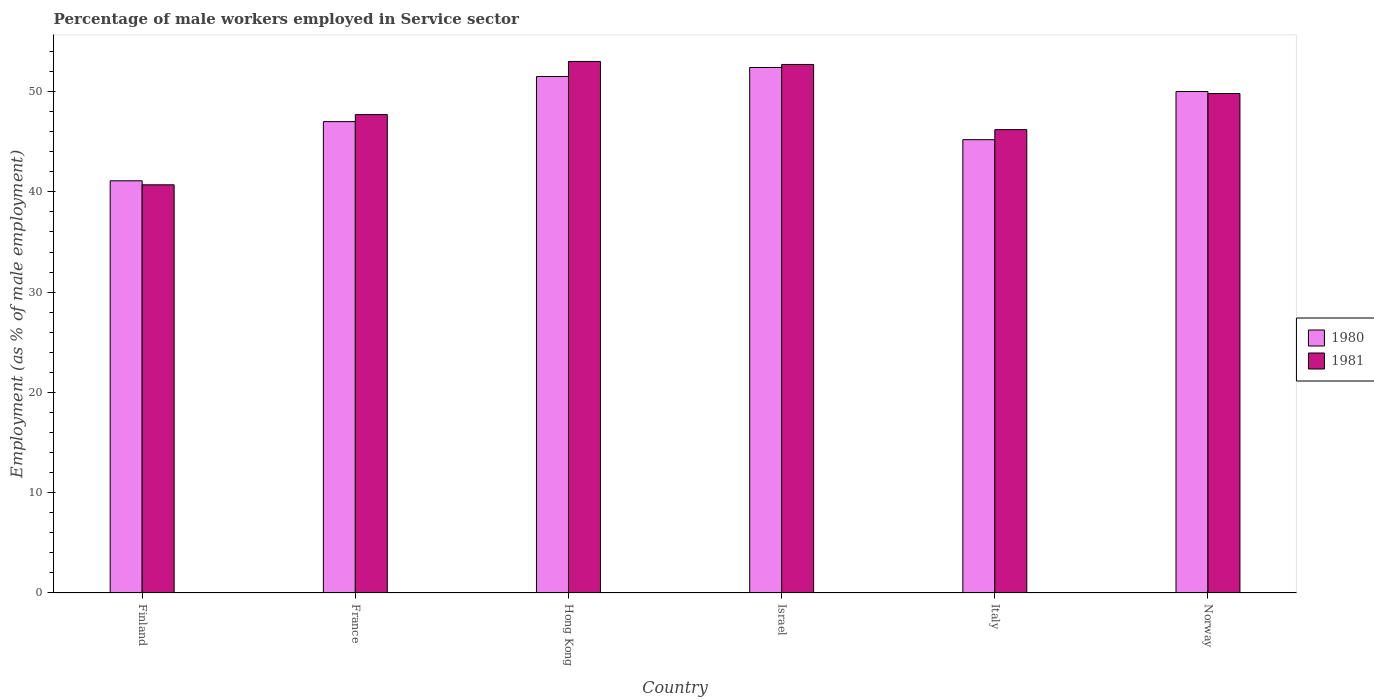How many groups of bars are there?
Ensure brevity in your answer.  6. How many bars are there on the 5th tick from the left?
Your answer should be compact. 2. What is the label of the 2nd group of bars from the left?
Offer a terse response. France. Across all countries, what is the maximum percentage of male workers employed in Service sector in 1981?
Offer a very short reply. 53. Across all countries, what is the minimum percentage of male workers employed in Service sector in 1980?
Your response must be concise. 41.1. What is the total percentage of male workers employed in Service sector in 1981 in the graph?
Your response must be concise. 290.1. What is the difference between the percentage of male workers employed in Service sector in 1981 in Finland and that in Hong Kong?
Your answer should be very brief. -12.3. What is the difference between the percentage of male workers employed in Service sector in 1980 in Finland and the percentage of male workers employed in Service sector in 1981 in Israel?
Provide a short and direct response. -11.6. What is the average percentage of male workers employed in Service sector in 1981 per country?
Ensure brevity in your answer.  48.35. What is the difference between the percentage of male workers employed in Service sector of/in 1980 and percentage of male workers employed in Service sector of/in 1981 in Israel?
Your answer should be compact. -0.3. What is the ratio of the percentage of male workers employed in Service sector in 1980 in Finland to that in Hong Kong?
Keep it short and to the point. 0.8. Is the percentage of male workers employed in Service sector in 1980 in Finland less than that in Hong Kong?
Offer a terse response. Yes. Is the difference between the percentage of male workers employed in Service sector in 1980 in Italy and Norway greater than the difference between the percentage of male workers employed in Service sector in 1981 in Italy and Norway?
Ensure brevity in your answer.  No. What is the difference between the highest and the lowest percentage of male workers employed in Service sector in 1981?
Provide a succinct answer. 12.3. In how many countries, is the percentage of male workers employed in Service sector in 1981 greater than the average percentage of male workers employed in Service sector in 1981 taken over all countries?
Ensure brevity in your answer.  3. How many bars are there?
Your answer should be compact. 12. Are all the bars in the graph horizontal?
Your answer should be very brief. No. How many countries are there in the graph?
Give a very brief answer. 6. What is the difference between two consecutive major ticks on the Y-axis?
Your response must be concise. 10. What is the title of the graph?
Ensure brevity in your answer.  Percentage of male workers employed in Service sector. Does "1994" appear as one of the legend labels in the graph?
Your answer should be very brief. No. What is the label or title of the Y-axis?
Ensure brevity in your answer.  Employment (as % of male employment). What is the Employment (as % of male employment) of 1980 in Finland?
Your answer should be very brief. 41.1. What is the Employment (as % of male employment) in 1981 in Finland?
Offer a terse response. 40.7. What is the Employment (as % of male employment) in 1980 in France?
Provide a succinct answer. 47. What is the Employment (as % of male employment) in 1981 in France?
Offer a terse response. 47.7. What is the Employment (as % of male employment) of 1980 in Hong Kong?
Your answer should be compact. 51.5. What is the Employment (as % of male employment) of 1980 in Israel?
Offer a terse response. 52.4. What is the Employment (as % of male employment) of 1981 in Israel?
Your response must be concise. 52.7. What is the Employment (as % of male employment) in 1980 in Italy?
Offer a very short reply. 45.2. What is the Employment (as % of male employment) in 1981 in Italy?
Your answer should be very brief. 46.2. What is the Employment (as % of male employment) of 1980 in Norway?
Your answer should be compact. 50. What is the Employment (as % of male employment) of 1981 in Norway?
Keep it short and to the point. 49.8. Across all countries, what is the maximum Employment (as % of male employment) in 1980?
Your answer should be compact. 52.4. Across all countries, what is the minimum Employment (as % of male employment) in 1980?
Give a very brief answer. 41.1. Across all countries, what is the minimum Employment (as % of male employment) in 1981?
Offer a very short reply. 40.7. What is the total Employment (as % of male employment) of 1980 in the graph?
Provide a succinct answer. 287.2. What is the total Employment (as % of male employment) in 1981 in the graph?
Your answer should be compact. 290.1. What is the difference between the Employment (as % of male employment) in 1980 in Finland and that in Israel?
Offer a very short reply. -11.3. What is the difference between the Employment (as % of male employment) of 1980 in Finland and that in Italy?
Provide a short and direct response. -4.1. What is the difference between the Employment (as % of male employment) in 1981 in Finland and that in Italy?
Provide a succinct answer. -5.5. What is the difference between the Employment (as % of male employment) in 1981 in Finland and that in Norway?
Provide a succinct answer. -9.1. What is the difference between the Employment (as % of male employment) in 1980 in France and that in Israel?
Your answer should be very brief. -5.4. What is the difference between the Employment (as % of male employment) of 1981 in France and that in Italy?
Offer a very short reply. 1.5. What is the difference between the Employment (as % of male employment) of 1980 in Hong Kong and that in Italy?
Your answer should be very brief. 6.3. What is the difference between the Employment (as % of male employment) of 1981 in Hong Kong and that in Italy?
Make the answer very short. 6.8. What is the difference between the Employment (as % of male employment) in 1980 in Hong Kong and that in Norway?
Provide a succinct answer. 1.5. What is the difference between the Employment (as % of male employment) of 1981 in Hong Kong and that in Norway?
Your answer should be very brief. 3.2. What is the difference between the Employment (as % of male employment) in 1981 in Israel and that in Italy?
Offer a very short reply. 6.5. What is the difference between the Employment (as % of male employment) in 1980 in Italy and that in Norway?
Give a very brief answer. -4.8. What is the difference between the Employment (as % of male employment) of 1981 in Italy and that in Norway?
Offer a very short reply. -3.6. What is the difference between the Employment (as % of male employment) in 1980 in Finland and the Employment (as % of male employment) in 1981 in France?
Your answer should be compact. -6.6. What is the difference between the Employment (as % of male employment) in 1980 in Finland and the Employment (as % of male employment) in 1981 in Hong Kong?
Ensure brevity in your answer.  -11.9. What is the difference between the Employment (as % of male employment) in 1980 in France and the Employment (as % of male employment) in 1981 in Italy?
Your response must be concise. 0.8. What is the difference between the Employment (as % of male employment) in 1980 in France and the Employment (as % of male employment) in 1981 in Norway?
Provide a short and direct response. -2.8. What is the difference between the Employment (as % of male employment) of 1980 in Hong Kong and the Employment (as % of male employment) of 1981 in Israel?
Your answer should be very brief. -1.2. What is the difference between the Employment (as % of male employment) of 1980 in Hong Kong and the Employment (as % of male employment) of 1981 in Italy?
Your answer should be compact. 5.3. What is the difference between the Employment (as % of male employment) of 1980 in Israel and the Employment (as % of male employment) of 1981 in Italy?
Ensure brevity in your answer.  6.2. What is the difference between the Employment (as % of male employment) of 1980 in Israel and the Employment (as % of male employment) of 1981 in Norway?
Your response must be concise. 2.6. What is the difference between the Employment (as % of male employment) of 1980 in Italy and the Employment (as % of male employment) of 1981 in Norway?
Keep it short and to the point. -4.6. What is the average Employment (as % of male employment) of 1980 per country?
Keep it short and to the point. 47.87. What is the average Employment (as % of male employment) of 1981 per country?
Offer a terse response. 48.35. What is the difference between the Employment (as % of male employment) of 1980 and Employment (as % of male employment) of 1981 in Finland?
Give a very brief answer. 0.4. What is the difference between the Employment (as % of male employment) in 1980 and Employment (as % of male employment) in 1981 in Israel?
Provide a short and direct response. -0.3. What is the difference between the Employment (as % of male employment) of 1980 and Employment (as % of male employment) of 1981 in Italy?
Ensure brevity in your answer.  -1. What is the difference between the Employment (as % of male employment) in 1980 and Employment (as % of male employment) in 1981 in Norway?
Your answer should be compact. 0.2. What is the ratio of the Employment (as % of male employment) in 1980 in Finland to that in France?
Provide a short and direct response. 0.87. What is the ratio of the Employment (as % of male employment) in 1981 in Finland to that in France?
Make the answer very short. 0.85. What is the ratio of the Employment (as % of male employment) of 1980 in Finland to that in Hong Kong?
Your answer should be very brief. 0.8. What is the ratio of the Employment (as % of male employment) of 1981 in Finland to that in Hong Kong?
Provide a succinct answer. 0.77. What is the ratio of the Employment (as % of male employment) in 1980 in Finland to that in Israel?
Your answer should be compact. 0.78. What is the ratio of the Employment (as % of male employment) of 1981 in Finland to that in Israel?
Provide a short and direct response. 0.77. What is the ratio of the Employment (as % of male employment) of 1980 in Finland to that in Italy?
Provide a succinct answer. 0.91. What is the ratio of the Employment (as % of male employment) in 1981 in Finland to that in Italy?
Your answer should be very brief. 0.88. What is the ratio of the Employment (as % of male employment) of 1980 in Finland to that in Norway?
Provide a short and direct response. 0.82. What is the ratio of the Employment (as % of male employment) in 1981 in Finland to that in Norway?
Keep it short and to the point. 0.82. What is the ratio of the Employment (as % of male employment) in 1980 in France to that in Hong Kong?
Your response must be concise. 0.91. What is the ratio of the Employment (as % of male employment) in 1980 in France to that in Israel?
Your answer should be compact. 0.9. What is the ratio of the Employment (as % of male employment) of 1981 in France to that in Israel?
Provide a short and direct response. 0.91. What is the ratio of the Employment (as % of male employment) of 1980 in France to that in Italy?
Provide a short and direct response. 1.04. What is the ratio of the Employment (as % of male employment) of 1981 in France to that in Italy?
Make the answer very short. 1.03. What is the ratio of the Employment (as % of male employment) of 1980 in France to that in Norway?
Ensure brevity in your answer.  0.94. What is the ratio of the Employment (as % of male employment) of 1981 in France to that in Norway?
Give a very brief answer. 0.96. What is the ratio of the Employment (as % of male employment) in 1980 in Hong Kong to that in Israel?
Ensure brevity in your answer.  0.98. What is the ratio of the Employment (as % of male employment) in 1981 in Hong Kong to that in Israel?
Ensure brevity in your answer.  1.01. What is the ratio of the Employment (as % of male employment) in 1980 in Hong Kong to that in Italy?
Offer a very short reply. 1.14. What is the ratio of the Employment (as % of male employment) in 1981 in Hong Kong to that in Italy?
Your answer should be compact. 1.15. What is the ratio of the Employment (as % of male employment) in 1981 in Hong Kong to that in Norway?
Your response must be concise. 1.06. What is the ratio of the Employment (as % of male employment) of 1980 in Israel to that in Italy?
Offer a terse response. 1.16. What is the ratio of the Employment (as % of male employment) of 1981 in Israel to that in Italy?
Offer a terse response. 1.14. What is the ratio of the Employment (as % of male employment) of 1980 in Israel to that in Norway?
Make the answer very short. 1.05. What is the ratio of the Employment (as % of male employment) in 1981 in Israel to that in Norway?
Ensure brevity in your answer.  1.06. What is the ratio of the Employment (as % of male employment) in 1980 in Italy to that in Norway?
Provide a short and direct response. 0.9. What is the ratio of the Employment (as % of male employment) in 1981 in Italy to that in Norway?
Provide a short and direct response. 0.93. What is the difference between the highest and the second highest Employment (as % of male employment) of 1980?
Give a very brief answer. 0.9. What is the difference between the highest and the lowest Employment (as % of male employment) of 1980?
Your response must be concise. 11.3. What is the difference between the highest and the lowest Employment (as % of male employment) of 1981?
Ensure brevity in your answer.  12.3. 